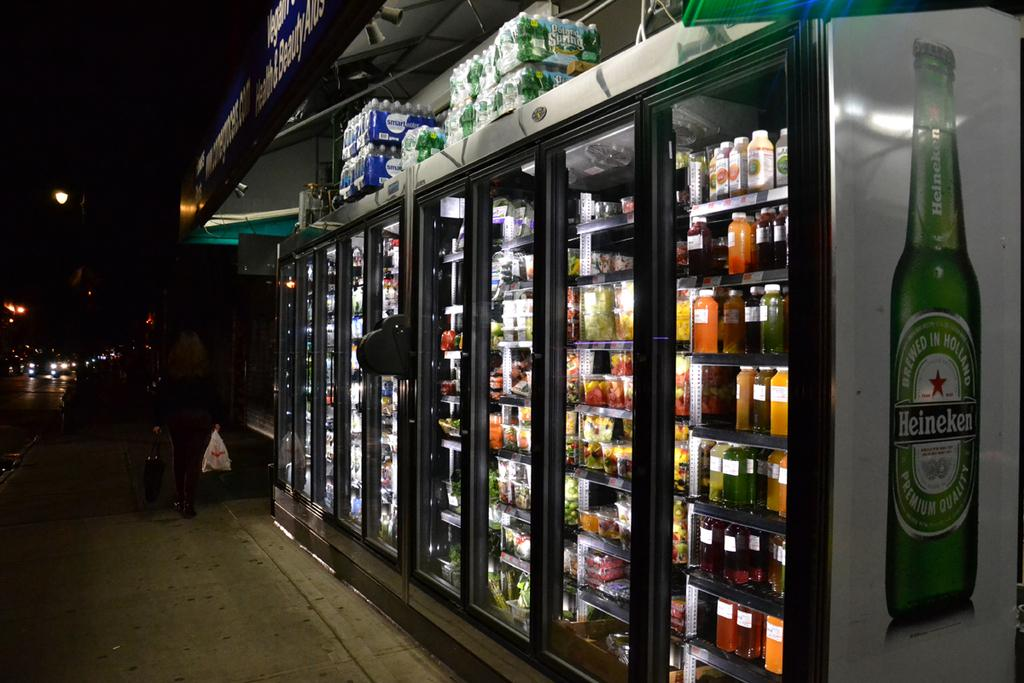<image>
Offer a succinct explanation of the picture presented. A Heineken bottle is displayed on the side of some supermarket fridges. 